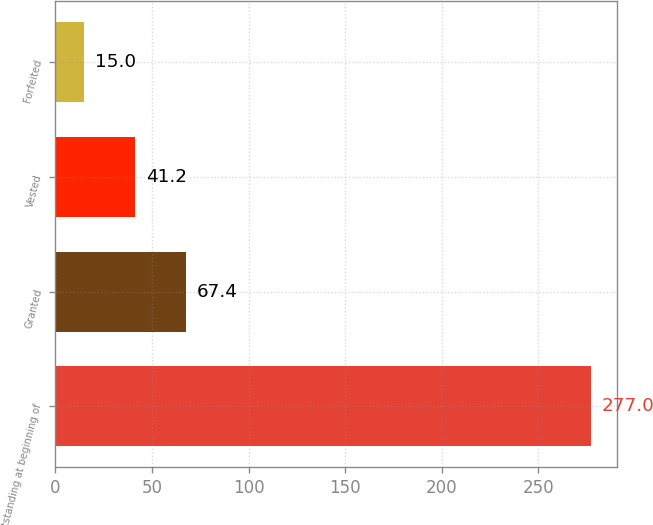Convert chart to OTSL. <chart><loc_0><loc_0><loc_500><loc_500><bar_chart><fcel>Outstanding at beginning of<fcel>Granted<fcel>Vested<fcel>Forfeited<nl><fcel>277<fcel>67.4<fcel>41.2<fcel>15<nl></chart> 